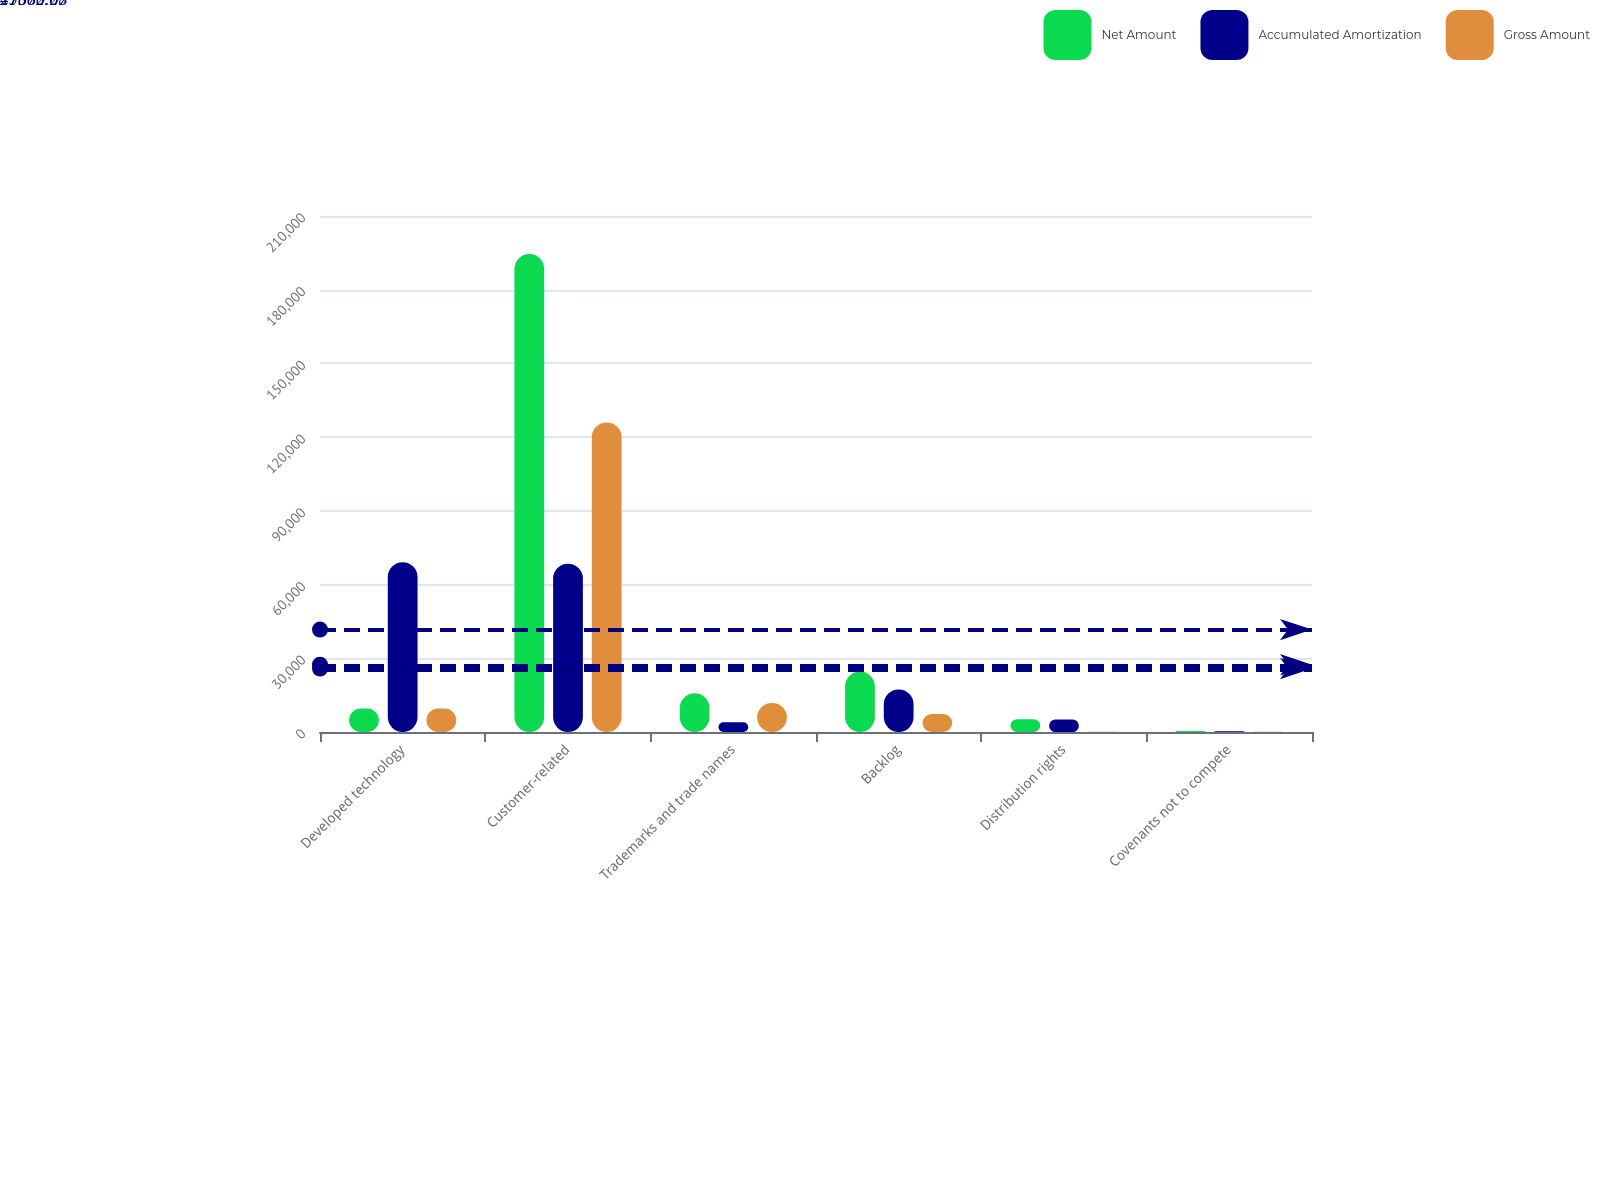Convert chart to OTSL. <chart><loc_0><loc_0><loc_500><loc_500><stacked_bar_chart><ecel><fcel>Developed technology<fcel>Customer-related<fcel>Trademarks and trade names<fcel>Backlog<fcel>Distribution rights<fcel>Covenants not to compete<nl><fcel>Net Amount<fcel>9544.5<fcel>194500<fcel>15730<fcel>24610<fcel>5236<fcel>400<nl><fcel>Accumulated Amortization<fcel>69107<fcel>68522<fcel>3941<fcel>17310<fcel>5101<fcel>333<nl><fcel>Gross Amount<fcel>9544.5<fcel>125978<fcel>11789<fcel>7300<fcel>135<fcel>67<nl></chart> 